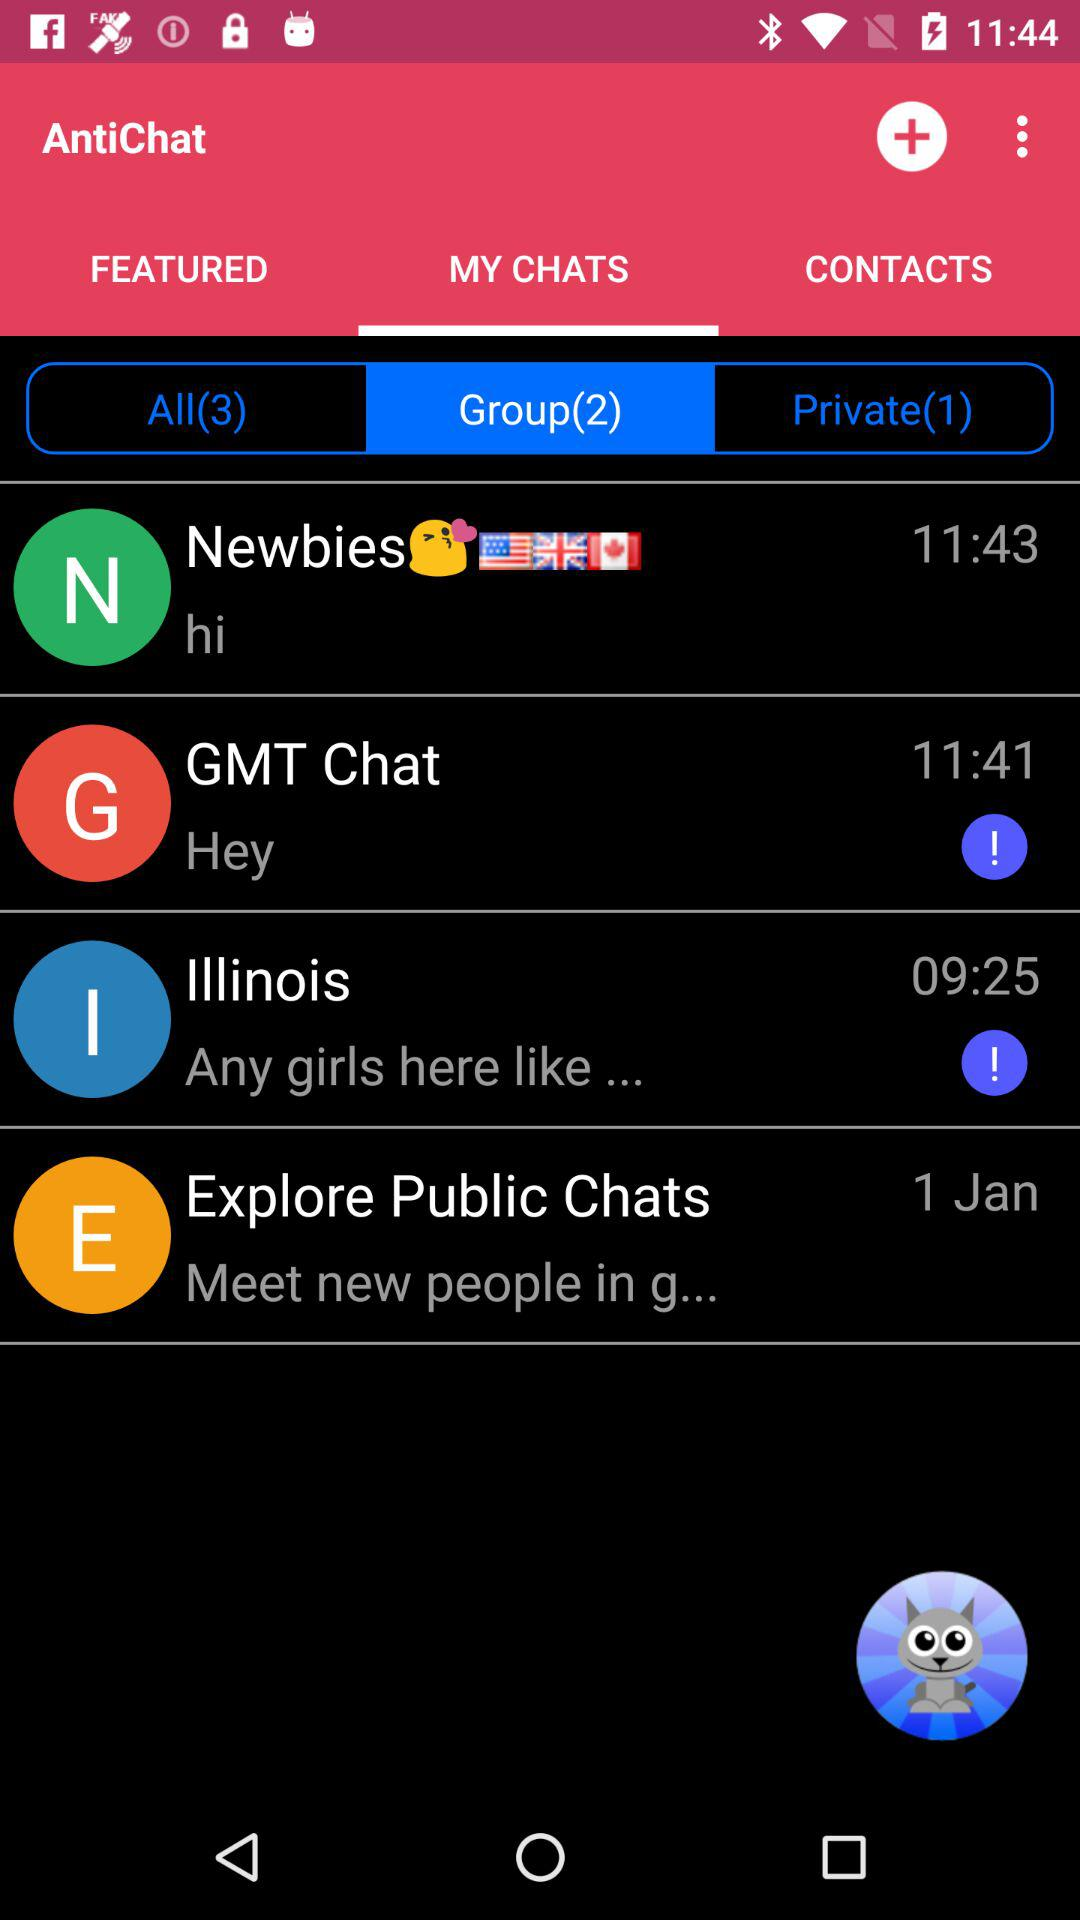How many private contacts do you have in Antichat?
When the provided information is insufficient, respond with <no answer>. <no answer> 